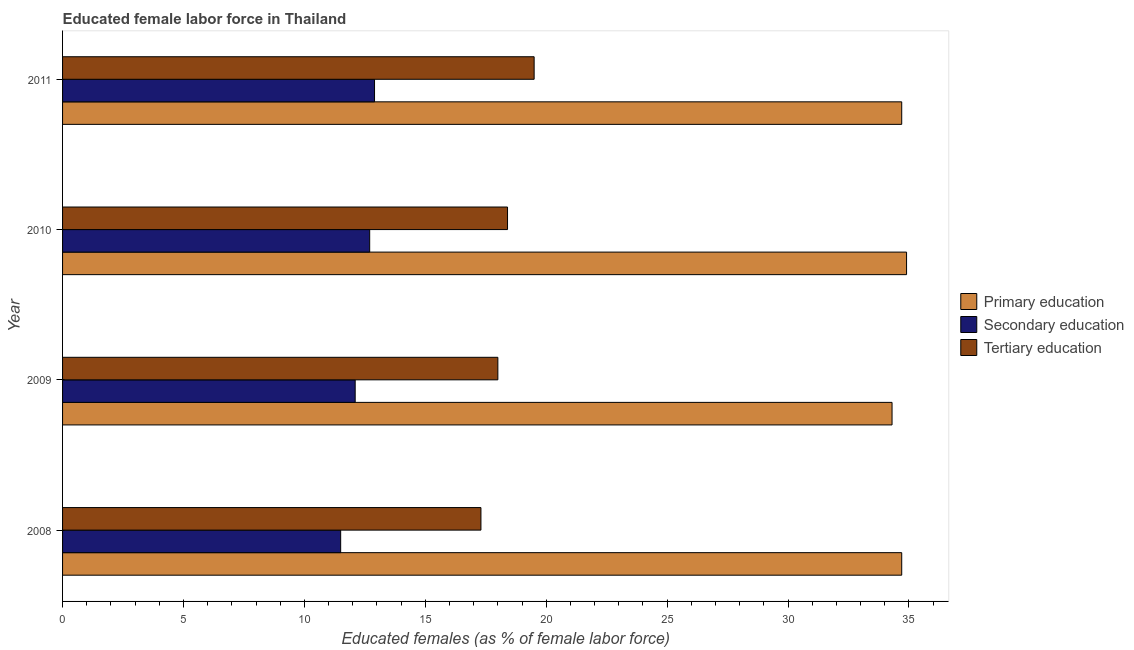Are the number of bars per tick equal to the number of legend labels?
Keep it short and to the point. Yes. Across all years, what is the maximum percentage of female labor force who received secondary education?
Your answer should be compact. 12.9. In which year was the percentage of female labor force who received secondary education maximum?
Your answer should be compact. 2011. In which year was the percentage of female labor force who received secondary education minimum?
Your answer should be very brief. 2008. What is the total percentage of female labor force who received tertiary education in the graph?
Provide a succinct answer. 73.2. What is the difference between the percentage of female labor force who received secondary education in 2009 and that in 2010?
Keep it short and to the point. -0.6. What is the difference between the percentage of female labor force who received primary education in 2008 and the percentage of female labor force who received secondary education in 2011?
Offer a very short reply. 21.8. In the year 2008, what is the difference between the percentage of female labor force who received primary education and percentage of female labor force who received secondary education?
Keep it short and to the point. 23.2. What is the ratio of the percentage of female labor force who received tertiary education in 2010 to that in 2011?
Make the answer very short. 0.94. Is the percentage of female labor force who received tertiary education in 2008 less than that in 2010?
Give a very brief answer. Yes. What is the difference between the highest and the lowest percentage of female labor force who received secondary education?
Make the answer very short. 1.4. In how many years, is the percentage of female labor force who received tertiary education greater than the average percentage of female labor force who received tertiary education taken over all years?
Ensure brevity in your answer.  2. Is the sum of the percentage of female labor force who received secondary education in 2010 and 2011 greater than the maximum percentage of female labor force who received primary education across all years?
Give a very brief answer. No. What does the 2nd bar from the top in 2010 represents?
Your answer should be very brief. Secondary education. What does the 1st bar from the bottom in 2008 represents?
Provide a short and direct response. Primary education. How many bars are there?
Keep it short and to the point. 12. Are all the bars in the graph horizontal?
Provide a succinct answer. Yes. How many years are there in the graph?
Your answer should be very brief. 4. What is the title of the graph?
Your answer should be compact. Educated female labor force in Thailand. Does "Primary" appear as one of the legend labels in the graph?
Offer a terse response. No. What is the label or title of the X-axis?
Your answer should be very brief. Educated females (as % of female labor force). What is the Educated females (as % of female labor force) of Primary education in 2008?
Your answer should be very brief. 34.7. What is the Educated females (as % of female labor force) of Tertiary education in 2008?
Your answer should be very brief. 17.3. What is the Educated females (as % of female labor force) in Primary education in 2009?
Your response must be concise. 34.3. What is the Educated females (as % of female labor force) in Secondary education in 2009?
Make the answer very short. 12.1. What is the Educated females (as % of female labor force) of Primary education in 2010?
Your answer should be compact. 34.9. What is the Educated females (as % of female labor force) of Secondary education in 2010?
Offer a very short reply. 12.7. What is the Educated females (as % of female labor force) of Tertiary education in 2010?
Keep it short and to the point. 18.4. What is the Educated females (as % of female labor force) in Primary education in 2011?
Your response must be concise. 34.7. What is the Educated females (as % of female labor force) of Secondary education in 2011?
Provide a succinct answer. 12.9. What is the Educated females (as % of female labor force) in Tertiary education in 2011?
Provide a succinct answer. 19.5. Across all years, what is the maximum Educated females (as % of female labor force) of Primary education?
Provide a short and direct response. 34.9. Across all years, what is the maximum Educated females (as % of female labor force) of Secondary education?
Give a very brief answer. 12.9. Across all years, what is the maximum Educated females (as % of female labor force) in Tertiary education?
Provide a short and direct response. 19.5. Across all years, what is the minimum Educated females (as % of female labor force) in Primary education?
Offer a terse response. 34.3. Across all years, what is the minimum Educated females (as % of female labor force) of Tertiary education?
Your answer should be very brief. 17.3. What is the total Educated females (as % of female labor force) in Primary education in the graph?
Provide a short and direct response. 138.6. What is the total Educated females (as % of female labor force) in Secondary education in the graph?
Your response must be concise. 49.2. What is the total Educated females (as % of female labor force) of Tertiary education in the graph?
Provide a succinct answer. 73.2. What is the difference between the Educated females (as % of female labor force) in Primary education in 2008 and that in 2009?
Ensure brevity in your answer.  0.4. What is the difference between the Educated females (as % of female labor force) in Tertiary education in 2008 and that in 2009?
Make the answer very short. -0.7. What is the difference between the Educated females (as % of female labor force) of Secondary education in 2008 and that in 2010?
Give a very brief answer. -1.2. What is the difference between the Educated females (as % of female labor force) in Primary education in 2008 and that in 2011?
Offer a terse response. 0. What is the difference between the Educated females (as % of female labor force) in Secondary education in 2008 and that in 2011?
Give a very brief answer. -1.4. What is the difference between the Educated females (as % of female labor force) in Secondary education in 2009 and that in 2010?
Your answer should be very brief. -0.6. What is the difference between the Educated females (as % of female labor force) of Primary education in 2009 and that in 2011?
Offer a terse response. -0.4. What is the difference between the Educated females (as % of female labor force) of Secondary education in 2009 and that in 2011?
Make the answer very short. -0.8. What is the difference between the Educated females (as % of female labor force) in Primary education in 2010 and that in 2011?
Ensure brevity in your answer.  0.2. What is the difference between the Educated females (as % of female labor force) of Tertiary education in 2010 and that in 2011?
Your answer should be very brief. -1.1. What is the difference between the Educated females (as % of female labor force) in Primary education in 2008 and the Educated females (as % of female labor force) in Secondary education in 2009?
Your response must be concise. 22.6. What is the difference between the Educated females (as % of female labor force) of Secondary education in 2008 and the Educated females (as % of female labor force) of Tertiary education in 2010?
Ensure brevity in your answer.  -6.9. What is the difference between the Educated females (as % of female labor force) of Primary education in 2008 and the Educated females (as % of female labor force) of Secondary education in 2011?
Provide a short and direct response. 21.8. What is the difference between the Educated females (as % of female labor force) of Primary education in 2008 and the Educated females (as % of female labor force) of Tertiary education in 2011?
Offer a terse response. 15.2. What is the difference between the Educated females (as % of female labor force) in Secondary education in 2008 and the Educated females (as % of female labor force) in Tertiary education in 2011?
Your answer should be compact. -8. What is the difference between the Educated females (as % of female labor force) in Primary education in 2009 and the Educated females (as % of female labor force) in Secondary education in 2010?
Your response must be concise. 21.6. What is the difference between the Educated females (as % of female labor force) in Primary education in 2009 and the Educated females (as % of female labor force) in Tertiary education in 2010?
Offer a terse response. 15.9. What is the difference between the Educated females (as % of female labor force) of Primary education in 2009 and the Educated females (as % of female labor force) of Secondary education in 2011?
Your answer should be compact. 21.4. What is the difference between the Educated females (as % of female labor force) of Primary education in 2009 and the Educated females (as % of female labor force) of Tertiary education in 2011?
Offer a terse response. 14.8. What is the difference between the Educated females (as % of female labor force) of Secondary education in 2009 and the Educated females (as % of female labor force) of Tertiary education in 2011?
Keep it short and to the point. -7.4. What is the difference between the Educated females (as % of female labor force) of Primary education in 2010 and the Educated females (as % of female labor force) of Secondary education in 2011?
Make the answer very short. 22. What is the average Educated females (as % of female labor force) in Primary education per year?
Provide a succinct answer. 34.65. What is the average Educated females (as % of female labor force) in Secondary education per year?
Make the answer very short. 12.3. What is the average Educated females (as % of female labor force) in Tertiary education per year?
Your response must be concise. 18.3. In the year 2008, what is the difference between the Educated females (as % of female labor force) of Primary education and Educated females (as % of female labor force) of Secondary education?
Your answer should be compact. 23.2. In the year 2008, what is the difference between the Educated females (as % of female labor force) of Secondary education and Educated females (as % of female labor force) of Tertiary education?
Your response must be concise. -5.8. In the year 2009, what is the difference between the Educated females (as % of female labor force) of Secondary education and Educated females (as % of female labor force) of Tertiary education?
Your response must be concise. -5.9. In the year 2010, what is the difference between the Educated females (as % of female labor force) in Secondary education and Educated females (as % of female labor force) in Tertiary education?
Your answer should be compact. -5.7. In the year 2011, what is the difference between the Educated females (as % of female labor force) in Primary education and Educated females (as % of female labor force) in Secondary education?
Provide a short and direct response. 21.8. In the year 2011, what is the difference between the Educated females (as % of female labor force) in Primary education and Educated females (as % of female labor force) in Tertiary education?
Your answer should be compact. 15.2. What is the ratio of the Educated females (as % of female labor force) of Primary education in 2008 to that in 2009?
Give a very brief answer. 1.01. What is the ratio of the Educated females (as % of female labor force) in Secondary education in 2008 to that in 2009?
Provide a short and direct response. 0.95. What is the ratio of the Educated females (as % of female labor force) in Tertiary education in 2008 to that in 2009?
Provide a short and direct response. 0.96. What is the ratio of the Educated females (as % of female labor force) in Primary education in 2008 to that in 2010?
Your answer should be very brief. 0.99. What is the ratio of the Educated females (as % of female labor force) in Secondary education in 2008 to that in 2010?
Your answer should be compact. 0.91. What is the ratio of the Educated females (as % of female labor force) in Tertiary education in 2008 to that in 2010?
Provide a succinct answer. 0.94. What is the ratio of the Educated females (as % of female labor force) of Primary education in 2008 to that in 2011?
Offer a terse response. 1. What is the ratio of the Educated females (as % of female labor force) of Secondary education in 2008 to that in 2011?
Provide a succinct answer. 0.89. What is the ratio of the Educated females (as % of female labor force) in Tertiary education in 2008 to that in 2011?
Give a very brief answer. 0.89. What is the ratio of the Educated females (as % of female labor force) of Primary education in 2009 to that in 2010?
Your response must be concise. 0.98. What is the ratio of the Educated females (as % of female labor force) in Secondary education in 2009 to that in 2010?
Make the answer very short. 0.95. What is the ratio of the Educated females (as % of female labor force) of Tertiary education in 2009 to that in 2010?
Keep it short and to the point. 0.98. What is the ratio of the Educated females (as % of female labor force) of Secondary education in 2009 to that in 2011?
Provide a succinct answer. 0.94. What is the ratio of the Educated females (as % of female labor force) of Tertiary education in 2009 to that in 2011?
Offer a terse response. 0.92. What is the ratio of the Educated females (as % of female labor force) of Primary education in 2010 to that in 2011?
Keep it short and to the point. 1.01. What is the ratio of the Educated females (as % of female labor force) of Secondary education in 2010 to that in 2011?
Offer a terse response. 0.98. What is the ratio of the Educated females (as % of female labor force) in Tertiary education in 2010 to that in 2011?
Keep it short and to the point. 0.94. What is the difference between the highest and the second highest Educated females (as % of female labor force) in Primary education?
Provide a short and direct response. 0.2. What is the difference between the highest and the second highest Educated females (as % of female labor force) of Secondary education?
Give a very brief answer. 0.2. What is the difference between the highest and the second highest Educated females (as % of female labor force) of Tertiary education?
Keep it short and to the point. 1.1. What is the difference between the highest and the lowest Educated females (as % of female labor force) in Secondary education?
Make the answer very short. 1.4. 